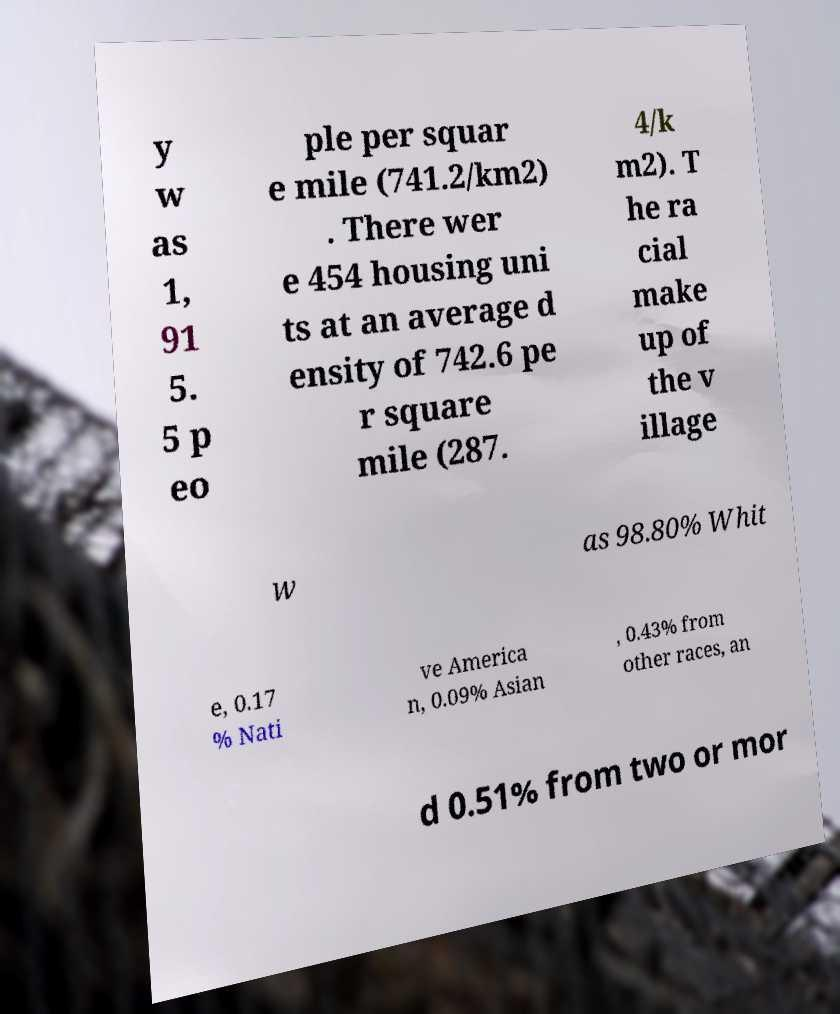What messages or text are displayed in this image? I need them in a readable, typed format. y w as 1, 91 5. 5 p eo ple per squar e mile (741.2/km2) . There wer e 454 housing uni ts at an average d ensity of 742.6 pe r square mile (287. 4/k m2). T he ra cial make up of the v illage w as 98.80% Whit e, 0.17 % Nati ve America n, 0.09% Asian , 0.43% from other races, an d 0.51% from two or mor 